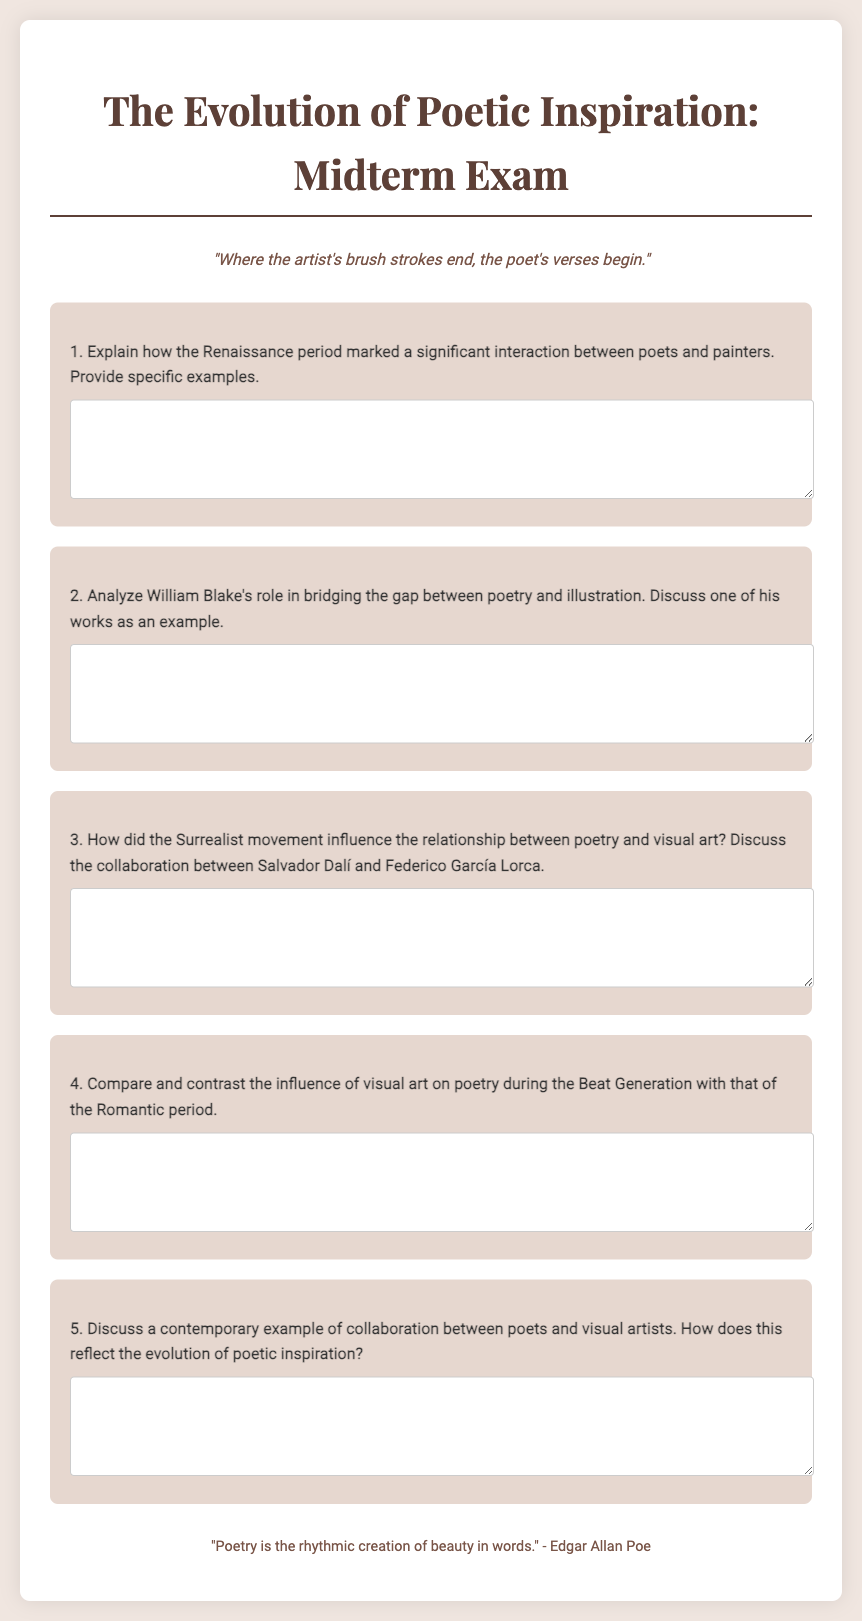What is the title of the midterm exam? The title of the midterm exam is provided at the top of the document, and it is "The Evolution of Poetic Inspiration: Midterm Exam."
Answer: The Evolution of Poetic Inspiration: Midterm Exam What artistic movement is mentioned in relation to both poetic inspiration and visual art? The document discusses several movements, but specifically mentions the Surrealist movement as influencing the relationship between poetry and visual art.
Answer: Surrealist movement Who is a poet associated with the collaboration with Salvador Dalí? The document states that Salvador Dalí collaborated with Federico García Lorca, highlighting their relationship in the context of Surrealism.
Answer: Federico García Lorca What phrase captures the essence of the document's theme regarding artists and poets? A phrase that encapsulates the theme can be found in the poem inspiration section: "Where the artist's brush strokes end, the poet's verses begin."
Answer: Where the artist's brush strokes end, the poet's verses begin What analysis is requested concerning William Blake? The document asks for an analysis of William Blake's role in bridging the gap between poetry and illustration, requesting a discussion of one of his works as an example.
Answer: Role of William Blake in bridging poetry and illustration 